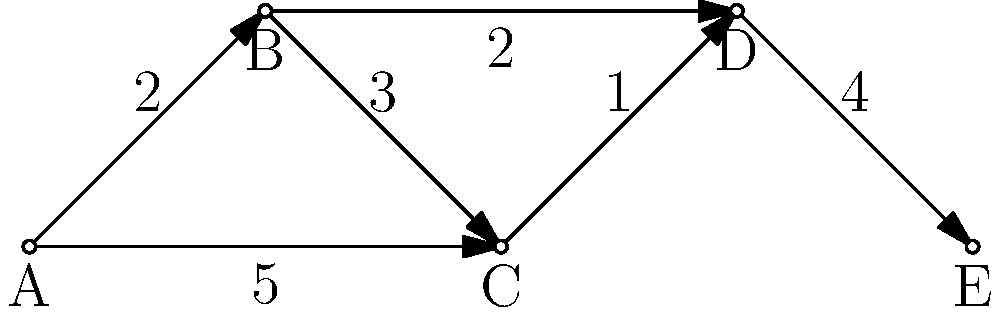In this supply chain network representing military logistics routes, nodes represent supply depots and edges represent transportation routes with associated costs. What is the minimum cost path from depot A to depot E, and how does this relate to efficient resource allocation in warfare? To find the minimum cost path from depot A to depot E, we need to analyze all possible paths and their associated costs:

1. Path A-B-C-D-E:
   Cost = 2 + 3 + 1 + 4 = 10

2. Path A-B-D-E:
   Cost = 2 + 2 + 4 = 8

3. Path A-C-D-E:
   Cost = 5 + 1 + 4 = 10

The minimum cost path is A-B-D-E with a total cost of 8.

This analysis relates to efficient resource allocation in warfare in several ways:

1. Cost minimization: By choosing the path with the lowest total cost, military logisticians can minimize resource expenditure on transportation.

2. Speed of supply: Lower-cost routes often correlate with faster or more direct paths, allowing for quicker resupply of front-line units.

3. Risk management: The chosen path may represent the best balance between cost and risk factors such as enemy interdiction or terrain difficulties.

4. Strategic planning: Understanding the most efficient supply routes can inform decisions on troop movements, base locations, and offensive/defensive strategies.

5. Resource allocation: By optimizing supply routes, more resources can be allocated to other critical areas of military operations.

6. Adaptability: In dynamic warfare situations, quickly identifying alternative efficient routes when certain paths become compromised is crucial.

The node-link diagram and path analysis demonstrate how quantitative methods can be applied to military logistics, showcasing the intersection of economic principles and warfare strategy.
Answer: A-B-D-E, cost 8; optimizes resource use, speed, and strategic flexibility in warfare. 